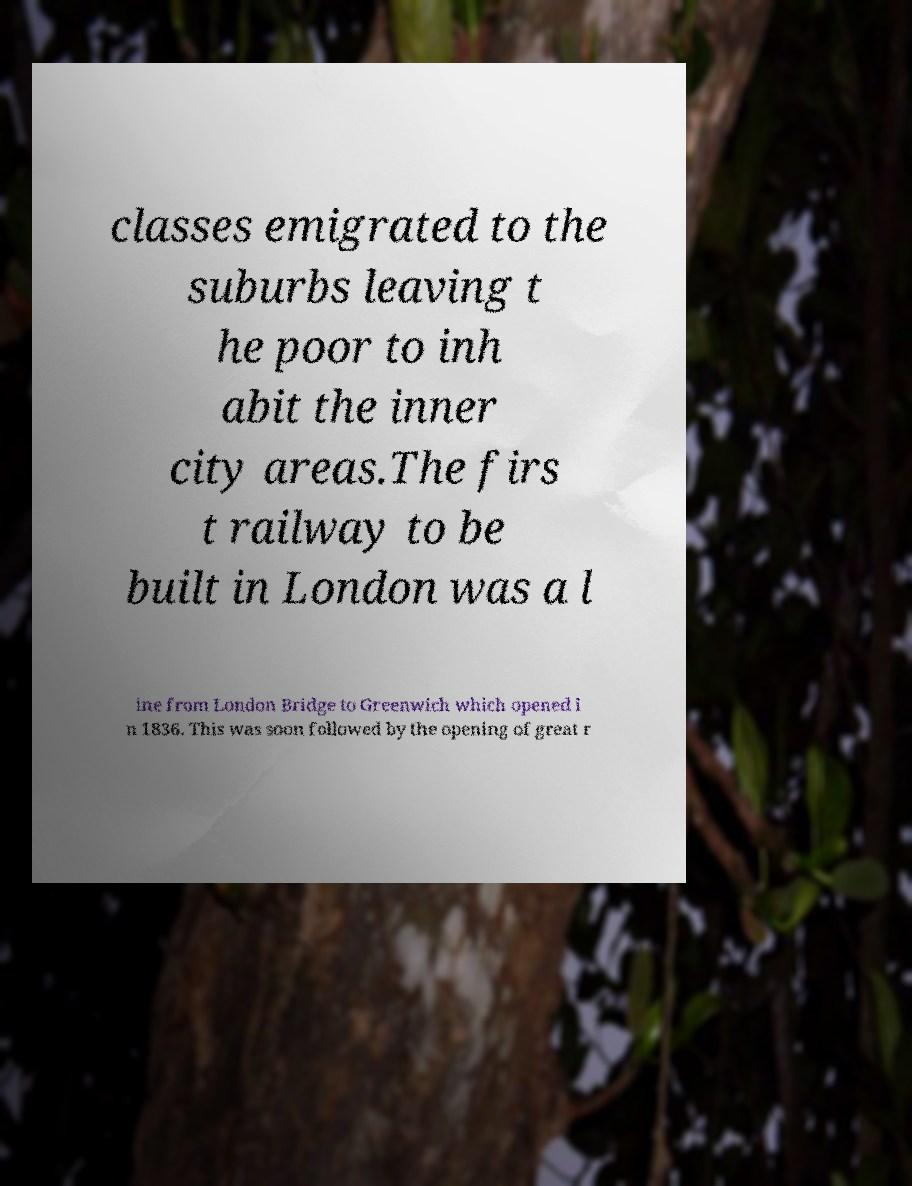What messages or text are displayed in this image? I need them in a readable, typed format. classes emigrated to the suburbs leaving t he poor to inh abit the inner city areas.The firs t railway to be built in London was a l ine from London Bridge to Greenwich which opened i n 1836. This was soon followed by the opening of great r 